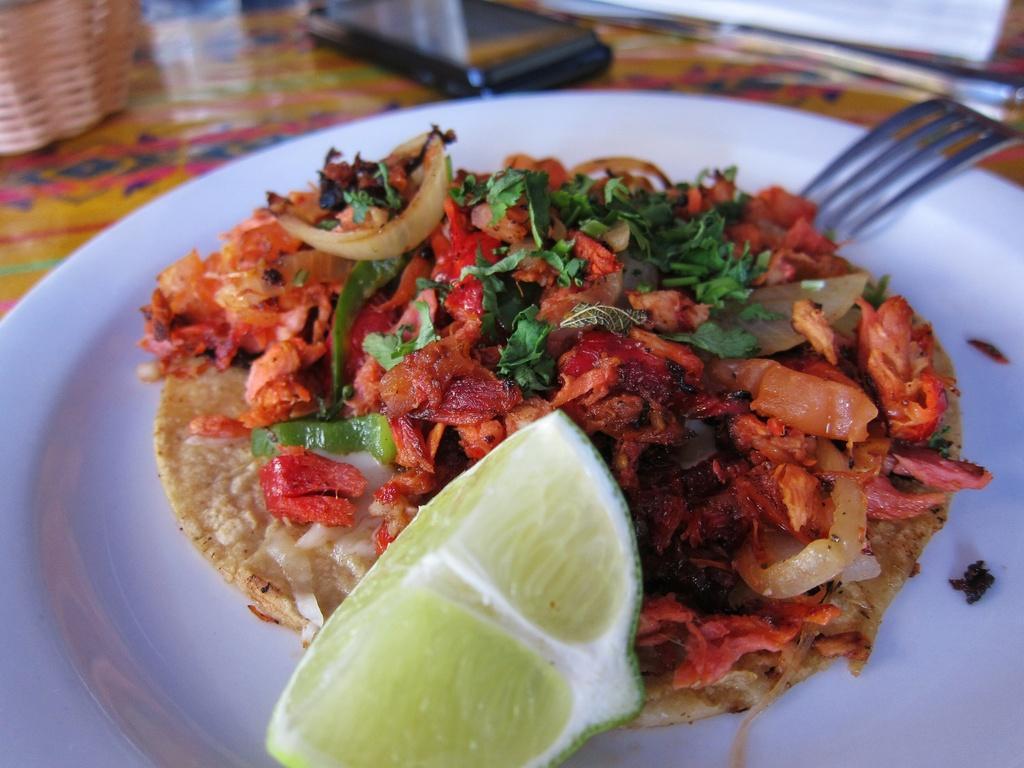Could you give a brief overview of what you see in this image? In this picture I can see a white plate in front and in the plate I can see food which is of cream, red, orange and green color. I can also see a piece of a lemon. On the right side of this picture I can see a fork. In the background I can see a black color thing and a basket. 